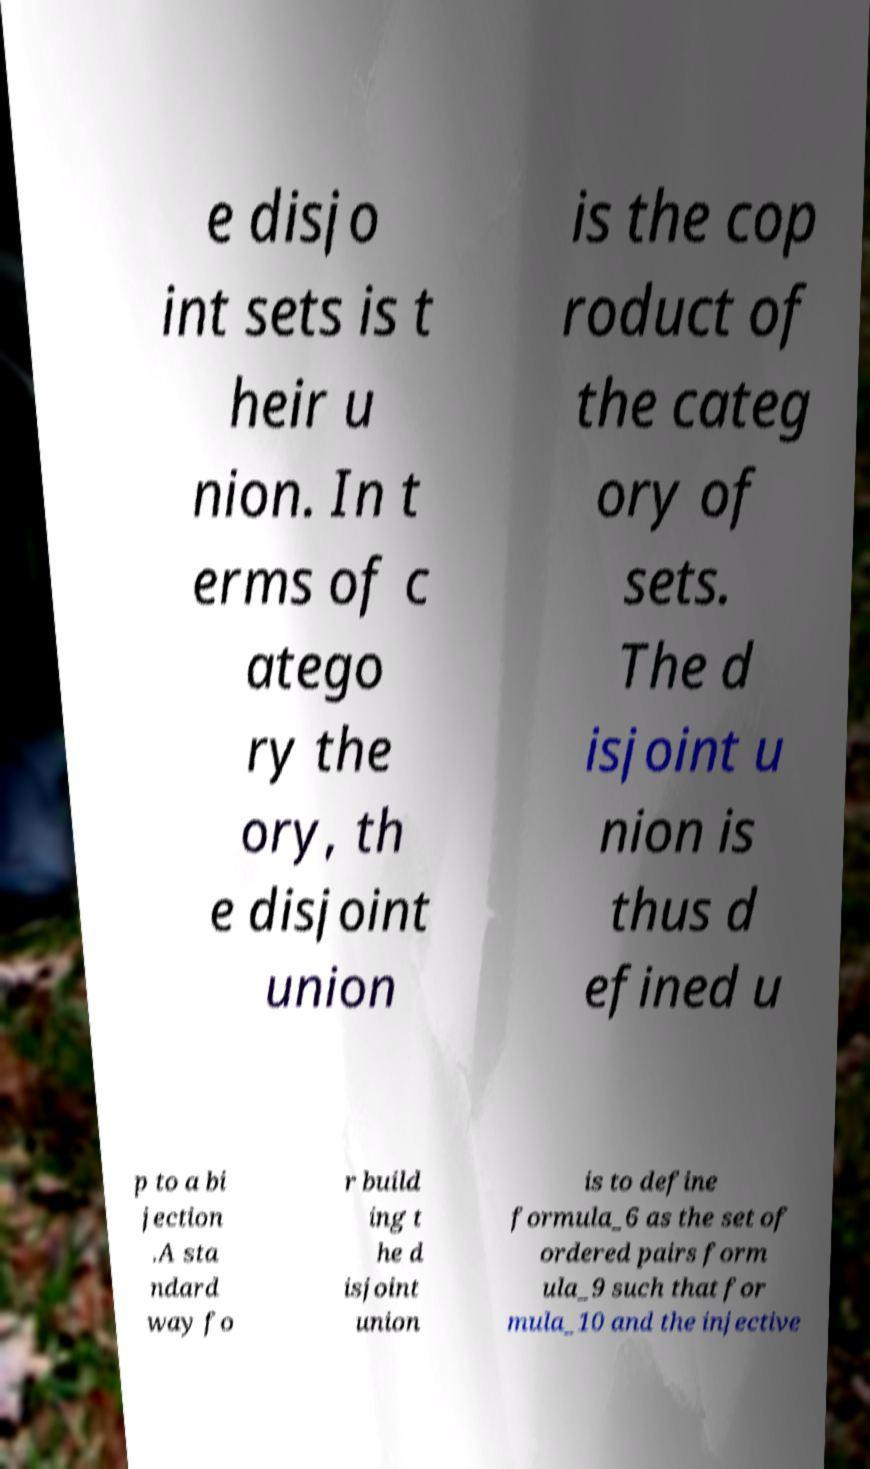What messages or text are displayed in this image? I need them in a readable, typed format. e disjo int sets is t heir u nion. In t erms of c atego ry the ory, th e disjoint union is the cop roduct of the categ ory of sets. The d isjoint u nion is thus d efined u p to a bi jection .A sta ndard way fo r build ing t he d isjoint union is to define formula_6 as the set of ordered pairs form ula_9 such that for mula_10 and the injective 